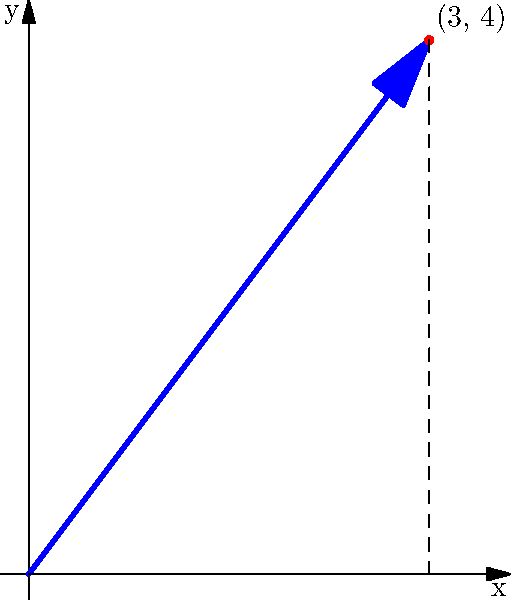In a coordinate plane where each unit represents one dragon egg, an arrow points from the origin to a point (3, 4). If this arrow represents a vector showing the direction and distance to hidden dragon eggs, what is the magnitude of this vector? Round your answer to two decimal places. To find the magnitude of a vector, we use the Pythagorean theorem:

1) The vector's components are:
   x-component = 3
   y-component = 4

2) Apply the Pythagorean theorem:
   $\text{magnitude} = \sqrt{x^2 + y^2}$

3) Substitute the values:
   $\text{magnitude} = \sqrt{3^2 + 4^2}$

4) Simplify:
   $\text{magnitude} = \sqrt{9 + 16} = \sqrt{25}$

5) Calculate the square root:
   $\text{magnitude} = 5$

Since the question asks for two decimal places and 5 is already a whole number, our final answer is 5.00 dragon eggs.
Answer: 5.00 